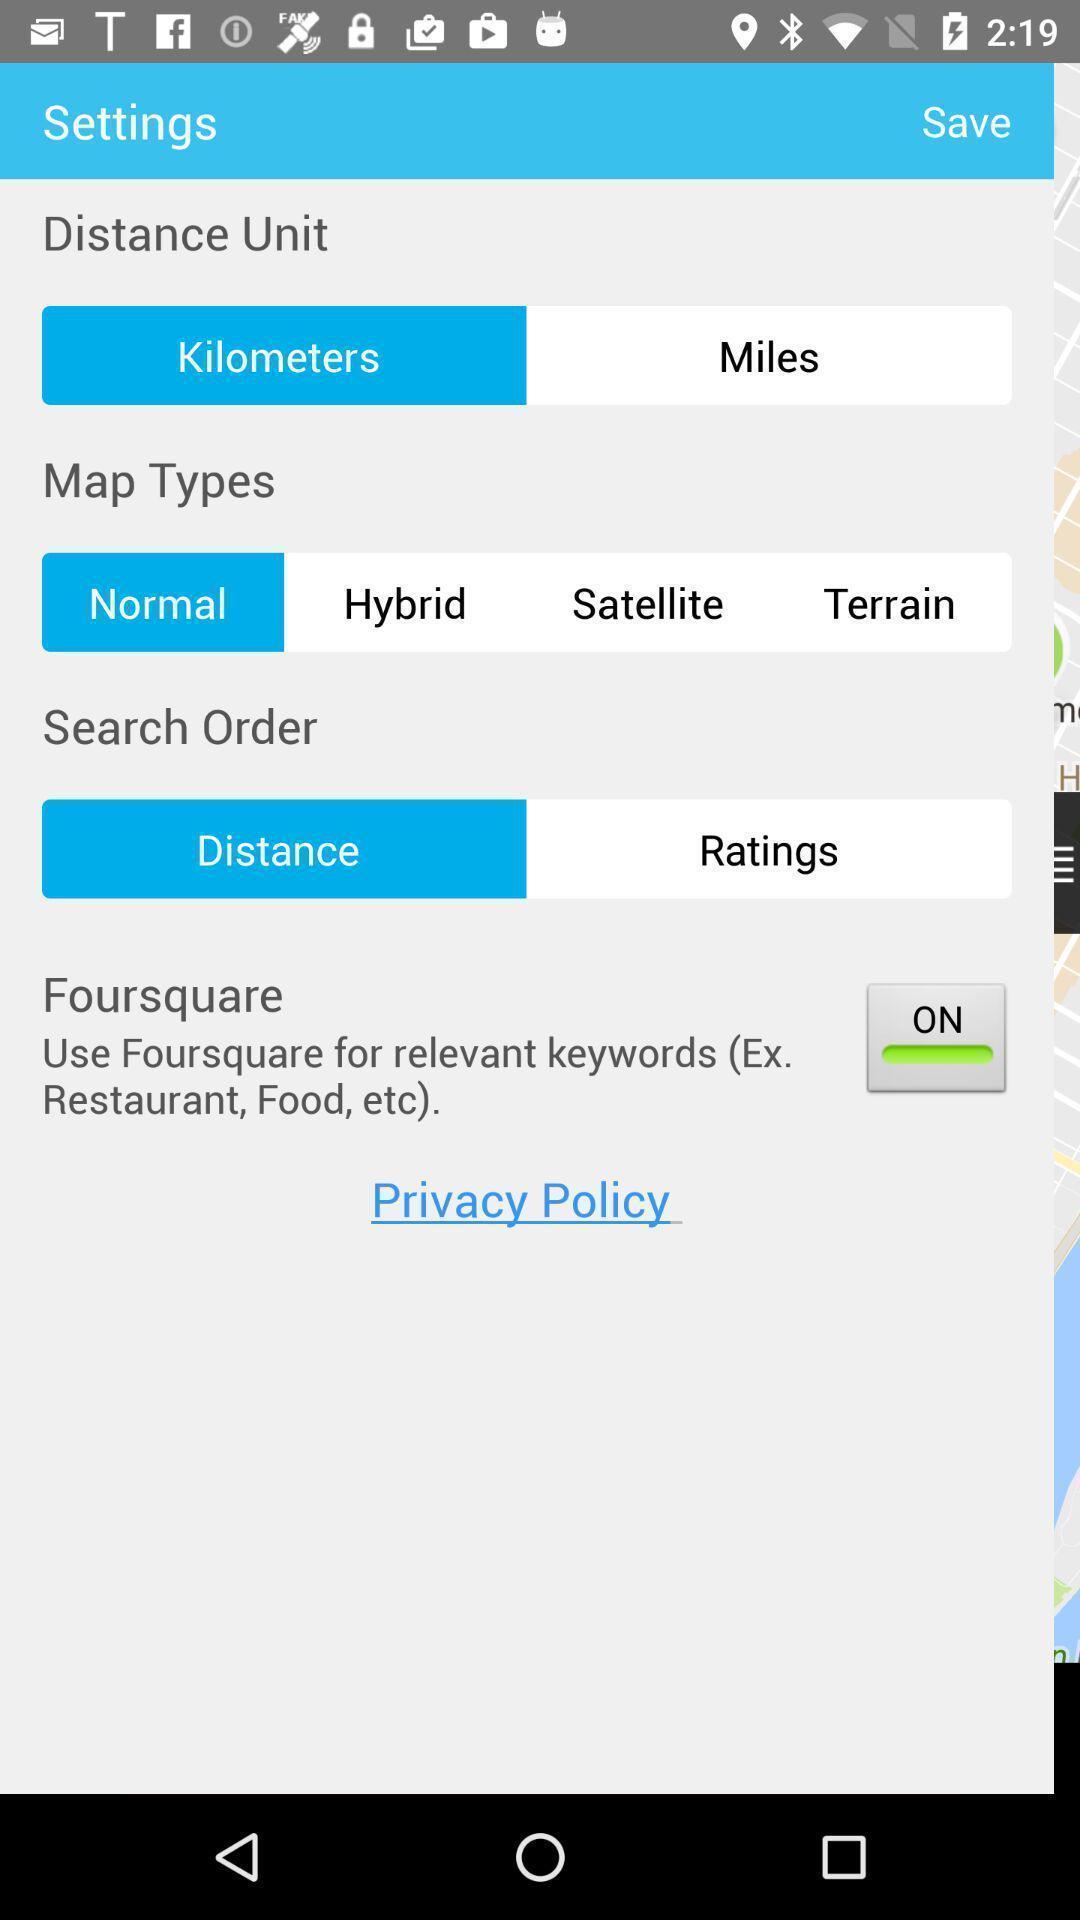Explain what's happening in this screen capture. Settings page. 